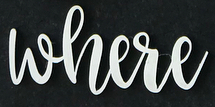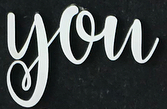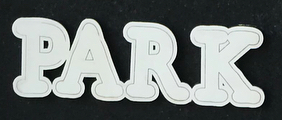What text appears in these images from left to right, separated by a semicolon? where; you; PARK 